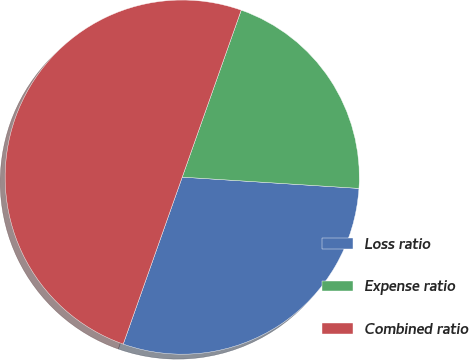Convert chart to OTSL. <chart><loc_0><loc_0><loc_500><loc_500><pie_chart><fcel>Loss ratio<fcel>Expense ratio<fcel>Combined ratio<nl><fcel>29.39%<fcel>20.61%<fcel>50.0%<nl></chart> 